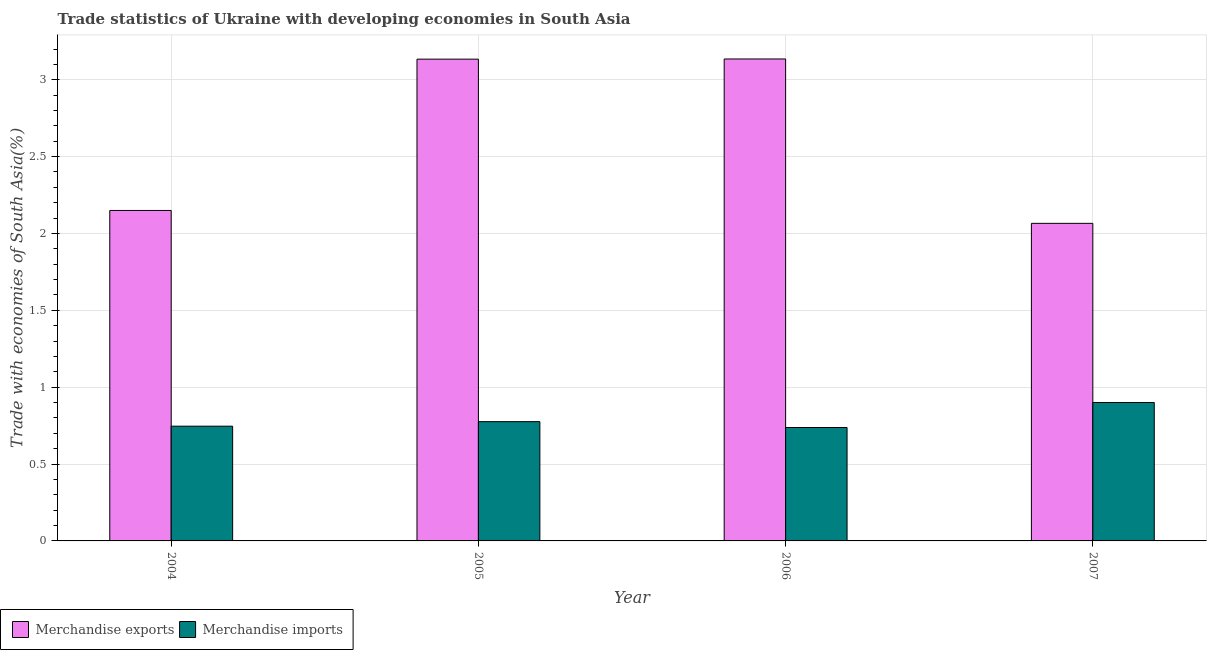How many groups of bars are there?
Keep it short and to the point. 4. What is the label of the 2nd group of bars from the left?
Your answer should be compact. 2005. In how many cases, is the number of bars for a given year not equal to the number of legend labels?
Give a very brief answer. 0. What is the merchandise exports in 2007?
Give a very brief answer. 2.07. Across all years, what is the maximum merchandise exports?
Provide a short and direct response. 3.14. Across all years, what is the minimum merchandise imports?
Give a very brief answer. 0.74. In which year was the merchandise exports minimum?
Offer a terse response. 2007. What is the total merchandise exports in the graph?
Offer a very short reply. 10.48. What is the difference between the merchandise imports in 2004 and that in 2007?
Offer a very short reply. -0.15. What is the difference between the merchandise exports in 2005 and the merchandise imports in 2006?
Offer a terse response. -0. What is the average merchandise exports per year?
Your response must be concise. 2.62. In the year 2004, what is the difference between the merchandise exports and merchandise imports?
Ensure brevity in your answer.  0. What is the ratio of the merchandise exports in 2004 to that in 2006?
Offer a very short reply. 0.69. Is the merchandise exports in 2004 less than that in 2007?
Offer a very short reply. No. What is the difference between the highest and the second highest merchandise exports?
Your response must be concise. 0. What is the difference between the highest and the lowest merchandise imports?
Make the answer very short. 0.16. In how many years, is the merchandise imports greater than the average merchandise imports taken over all years?
Your answer should be compact. 1. What does the 2nd bar from the left in 2004 represents?
Your answer should be very brief. Merchandise imports. What does the 2nd bar from the right in 2007 represents?
Keep it short and to the point. Merchandise exports. What is the difference between two consecutive major ticks on the Y-axis?
Offer a very short reply. 0.5. Does the graph contain grids?
Provide a succinct answer. Yes. How many legend labels are there?
Your answer should be very brief. 2. How are the legend labels stacked?
Provide a succinct answer. Horizontal. What is the title of the graph?
Offer a terse response. Trade statistics of Ukraine with developing economies in South Asia. What is the label or title of the X-axis?
Ensure brevity in your answer.  Year. What is the label or title of the Y-axis?
Offer a terse response. Trade with economies of South Asia(%). What is the Trade with economies of South Asia(%) of Merchandise exports in 2004?
Make the answer very short. 2.15. What is the Trade with economies of South Asia(%) in Merchandise imports in 2004?
Offer a terse response. 0.75. What is the Trade with economies of South Asia(%) of Merchandise exports in 2005?
Ensure brevity in your answer.  3.13. What is the Trade with economies of South Asia(%) in Merchandise imports in 2005?
Offer a terse response. 0.78. What is the Trade with economies of South Asia(%) in Merchandise exports in 2006?
Your answer should be very brief. 3.14. What is the Trade with economies of South Asia(%) of Merchandise imports in 2006?
Your answer should be compact. 0.74. What is the Trade with economies of South Asia(%) of Merchandise exports in 2007?
Ensure brevity in your answer.  2.07. What is the Trade with economies of South Asia(%) in Merchandise imports in 2007?
Your answer should be compact. 0.9. Across all years, what is the maximum Trade with economies of South Asia(%) in Merchandise exports?
Provide a succinct answer. 3.14. Across all years, what is the maximum Trade with economies of South Asia(%) in Merchandise imports?
Provide a short and direct response. 0.9. Across all years, what is the minimum Trade with economies of South Asia(%) in Merchandise exports?
Ensure brevity in your answer.  2.07. Across all years, what is the minimum Trade with economies of South Asia(%) of Merchandise imports?
Make the answer very short. 0.74. What is the total Trade with economies of South Asia(%) in Merchandise exports in the graph?
Your response must be concise. 10.48. What is the total Trade with economies of South Asia(%) of Merchandise imports in the graph?
Your response must be concise. 3.16. What is the difference between the Trade with economies of South Asia(%) of Merchandise exports in 2004 and that in 2005?
Ensure brevity in your answer.  -0.98. What is the difference between the Trade with economies of South Asia(%) of Merchandise imports in 2004 and that in 2005?
Ensure brevity in your answer.  -0.03. What is the difference between the Trade with economies of South Asia(%) of Merchandise exports in 2004 and that in 2006?
Your answer should be compact. -0.99. What is the difference between the Trade with economies of South Asia(%) of Merchandise imports in 2004 and that in 2006?
Ensure brevity in your answer.  0.01. What is the difference between the Trade with economies of South Asia(%) in Merchandise exports in 2004 and that in 2007?
Your answer should be very brief. 0.08. What is the difference between the Trade with economies of South Asia(%) in Merchandise imports in 2004 and that in 2007?
Make the answer very short. -0.15. What is the difference between the Trade with economies of South Asia(%) of Merchandise exports in 2005 and that in 2006?
Provide a succinct answer. -0. What is the difference between the Trade with economies of South Asia(%) in Merchandise imports in 2005 and that in 2006?
Give a very brief answer. 0.04. What is the difference between the Trade with economies of South Asia(%) of Merchandise exports in 2005 and that in 2007?
Offer a very short reply. 1.07. What is the difference between the Trade with economies of South Asia(%) in Merchandise imports in 2005 and that in 2007?
Offer a very short reply. -0.12. What is the difference between the Trade with economies of South Asia(%) of Merchandise exports in 2006 and that in 2007?
Your answer should be very brief. 1.07. What is the difference between the Trade with economies of South Asia(%) of Merchandise imports in 2006 and that in 2007?
Offer a terse response. -0.16. What is the difference between the Trade with economies of South Asia(%) in Merchandise exports in 2004 and the Trade with economies of South Asia(%) in Merchandise imports in 2005?
Keep it short and to the point. 1.37. What is the difference between the Trade with economies of South Asia(%) in Merchandise exports in 2004 and the Trade with economies of South Asia(%) in Merchandise imports in 2006?
Keep it short and to the point. 1.41. What is the difference between the Trade with economies of South Asia(%) of Merchandise exports in 2004 and the Trade with economies of South Asia(%) of Merchandise imports in 2007?
Offer a very short reply. 1.25. What is the difference between the Trade with economies of South Asia(%) in Merchandise exports in 2005 and the Trade with economies of South Asia(%) in Merchandise imports in 2006?
Make the answer very short. 2.4. What is the difference between the Trade with economies of South Asia(%) in Merchandise exports in 2005 and the Trade with economies of South Asia(%) in Merchandise imports in 2007?
Keep it short and to the point. 2.23. What is the difference between the Trade with economies of South Asia(%) in Merchandise exports in 2006 and the Trade with economies of South Asia(%) in Merchandise imports in 2007?
Provide a succinct answer. 2.23. What is the average Trade with economies of South Asia(%) in Merchandise exports per year?
Ensure brevity in your answer.  2.62. What is the average Trade with economies of South Asia(%) in Merchandise imports per year?
Give a very brief answer. 0.79. In the year 2004, what is the difference between the Trade with economies of South Asia(%) in Merchandise exports and Trade with economies of South Asia(%) in Merchandise imports?
Provide a succinct answer. 1.4. In the year 2005, what is the difference between the Trade with economies of South Asia(%) in Merchandise exports and Trade with economies of South Asia(%) in Merchandise imports?
Ensure brevity in your answer.  2.36. In the year 2006, what is the difference between the Trade with economies of South Asia(%) in Merchandise exports and Trade with economies of South Asia(%) in Merchandise imports?
Offer a terse response. 2.4. In the year 2007, what is the difference between the Trade with economies of South Asia(%) of Merchandise exports and Trade with economies of South Asia(%) of Merchandise imports?
Keep it short and to the point. 1.17. What is the ratio of the Trade with economies of South Asia(%) in Merchandise exports in 2004 to that in 2005?
Ensure brevity in your answer.  0.69. What is the ratio of the Trade with economies of South Asia(%) in Merchandise imports in 2004 to that in 2005?
Ensure brevity in your answer.  0.96. What is the ratio of the Trade with economies of South Asia(%) in Merchandise exports in 2004 to that in 2006?
Give a very brief answer. 0.69. What is the ratio of the Trade with economies of South Asia(%) in Merchandise imports in 2004 to that in 2006?
Offer a very short reply. 1.01. What is the ratio of the Trade with economies of South Asia(%) in Merchandise exports in 2004 to that in 2007?
Ensure brevity in your answer.  1.04. What is the ratio of the Trade with economies of South Asia(%) in Merchandise imports in 2004 to that in 2007?
Keep it short and to the point. 0.83. What is the ratio of the Trade with economies of South Asia(%) in Merchandise imports in 2005 to that in 2006?
Your answer should be very brief. 1.05. What is the ratio of the Trade with economies of South Asia(%) in Merchandise exports in 2005 to that in 2007?
Offer a terse response. 1.52. What is the ratio of the Trade with economies of South Asia(%) in Merchandise imports in 2005 to that in 2007?
Offer a very short reply. 0.86. What is the ratio of the Trade with economies of South Asia(%) of Merchandise exports in 2006 to that in 2007?
Give a very brief answer. 1.52. What is the ratio of the Trade with economies of South Asia(%) in Merchandise imports in 2006 to that in 2007?
Your response must be concise. 0.82. What is the difference between the highest and the second highest Trade with economies of South Asia(%) of Merchandise exports?
Offer a terse response. 0. What is the difference between the highest and the second highest Trade with economies of South Asia(%) in Merchandise imports?
Give a very brief answer. 0.12. What is the difference between the highest and the lowest Trade with economies of South Asia(%) of Merchandise exports?
Your answer should be compact. 1.07. What is the difference between the highest and the lowest Trade with economies of South Asia(%) in Merchandise imports?
Offer a terse response. 0.16. 